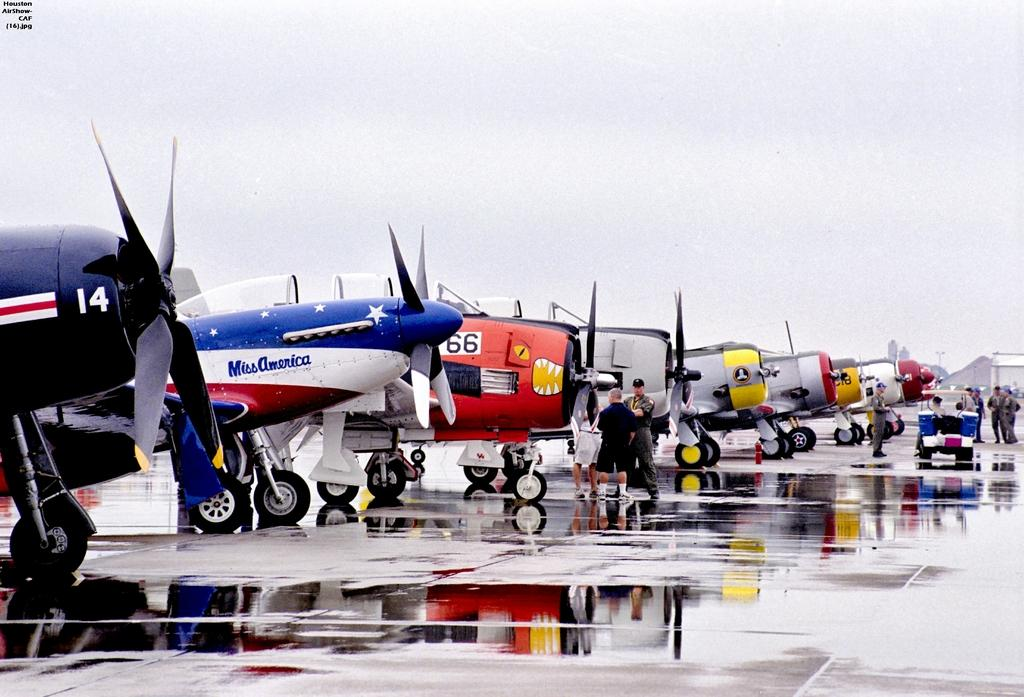What are the people in the image doing? The people in the image are standing on the ground. What else can be seen in the image besides the people? There is a vehicle and airplanes on the ground in the image. What is visible in the background of the image? The sky is visible in the background of the image. Where is the mailbox located in the image? There is no mailbox present in the image. Can you see any fairies flying around in the image? There are no fairies present in the image. 